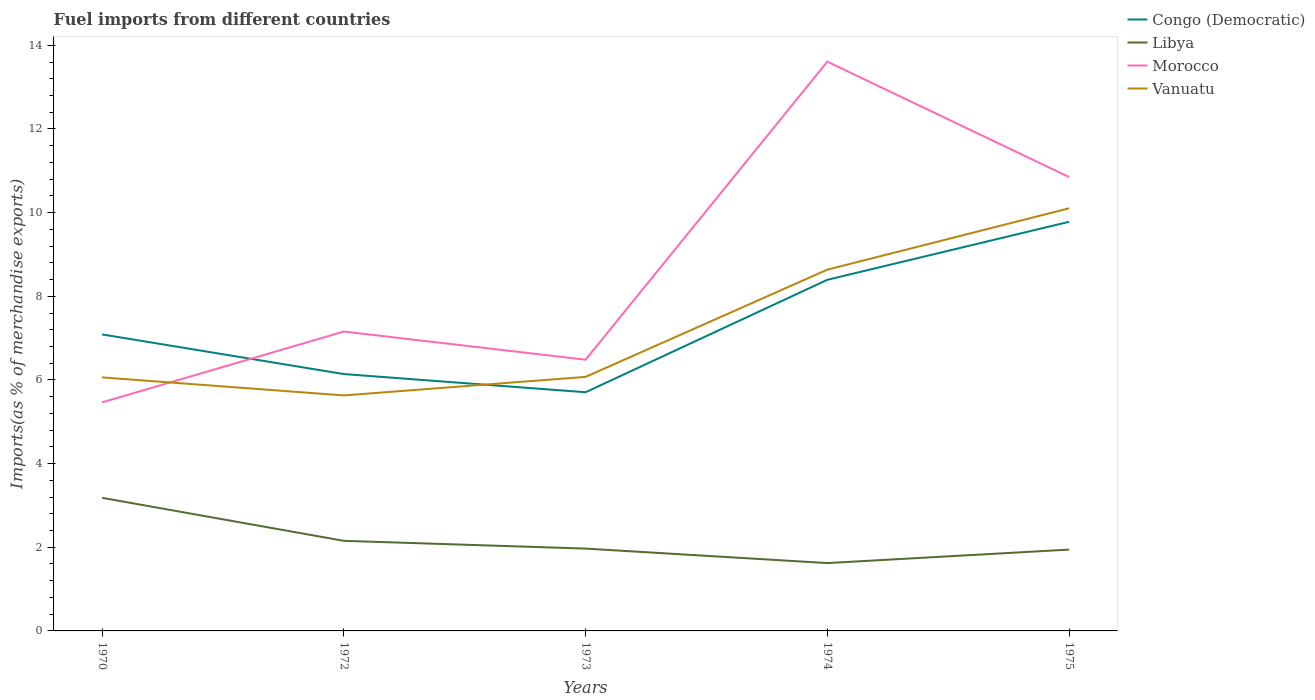How many different coloured lines are there?
Keep it short and to the point. 4. Does the line corresponding to Vanuatu intersect with the line corresponding to Libya?
Provide a succinct answer. No. Is the number of lines equal to the number of legend labels?
Provide a short and direct response. Yes. Across all years, what is the maximum percentage of imports to different countries in Congo (Democratic)?
Your answer should be compact. 5.71. What is the total percentage of imports to different countries in Congo (Democratic) in the graph?
Offer a terse response. 0.95. What is the difference between the highest and the second highest percentage of imports to different countries in Vanuatu?
Keep it short and to the point. 4.47. How many lines are there?
Give a very brief answer. 4. How many years are there in the graph?
Offer a very short reply. 5. Are the values on the major ticks of Y-axis written in scientific E-notation?
Give a very brief answer. No. Does the graph contain any zero values?
Keep it short and to the point. No. Where does the legend appear in the graph?
Ensure brevity in your answer.  Top right. How many legend labels are there?
Give a very brief answer. 4. What is the title of the graph?
Offer a very short reply. Fuel imports from different countries. Does "Finland" appear as one of the legend labels in the graph?
Make the answer very short. No. What is the label or title of the X-axis?
Offer a terse response. Years. What is the label or title of the Y-axis?
Your answer should be compact. Imports(as % of merchandise exports). What is the Imports(as % of merchandise exports) in Congo (Democratic) in 1970?
Ensure brevity in your answer.  7.09. What is the Imports(as % of merchandise exports) in Libya in 1970?
Your answer should be compact. 3.18. What is the Imports(as % of merchandise exports) of Morocco in 1970?
Provide a short and direct response. 5.46. What is the Imports(as % of merchandise exports) in Vanuatu in 1970?
Your response must be concise. 6.06. What is the Imports(as % of merchandise exports) in Congo (Democratic) in 1972?
Provide a succinct answer. 6.14. What is the Imports(as % of merchandise exports) of Libya in 1972?
Your answer should be very brief. 2.15. What is the Imports(as % of merchandise exports) of Morocco in 1972?
Ensure brevity in your answer.  7.16. What is the Imports(as % of merchandise exports) in Vanuatu in 1972?
Your response must be concise. 5.63. What is the Imports(as % of merchandise exports) in Congo (Democratic) in 1973?
Your response must be concise. 5.71. What is the Imports(as % of merchandise exports) in Libya in 1973?
Offer a very short reply. 1.97. What is the Imports(as % of merchandise exports) of Morocco in 1973?
Provide a short and direct response. 6.48. What is the Imports(as % of merchandise exports) in Vanuatu in 1973?
Make the answer very short. 6.07. What is the Imports(as % of merchandise exports) of Congo (Democratic) in 1974?
Offer a terse response. 8.39. What is the Imports(as % of merchandise exports) in Libya in 1974?
Keep it short and to the point. 1.62. What is the Imports(as % of merchandise exports) of Morocco in 1974?
Your answer should be very brief. 13.61. What is the Imports(as % of merchandise exports) of Vanuatu in 1974?
Offer a terse response. 8.64. What is the Imports(as % of merchandise exports) of Congo (Democratic) in 1975?
Your answer should be compact. 9.78. What is the Imports(as % of merchandise exports) in Libya in 1975?
Your response must be concise. 1.94. What is the Imports(as % of merchandise exports) in Morocco in 1975?
Your answer should be compact. 10.85. What is the Imports(as % of merchandise exports) in Vanuatu in 1975?
Your response must be concise. 10.1. Across all years, what is the maximum Imports(as % of merchandise exports) in Congo (Democratic)?
Keep it short and to the point. 9.78. Across all years, what is the maximum Imports(as % of merchandise exports) in Libya?
Offer a terse response. 3.18. Across all years, what is the maximum Imports(as % of merchandise exports) in Morocco?
Ensure brevity in your answer.  13.61. Across all years, what is the maximum Imports(as % of merchandise exports) of Vanuatu?
Ensure brevity in your answer.  10.1. Across all years, what is the minimum Imports(as % of merchandise exports) of Congo (Democratic)?
Offer a terse response. 5.71. Across all years, what is the minimum Imports(as % of merchandise exports) of Libya?
Your answer should be very brief. 1.62. Across all years, what is the minimum Imports(as % of merchandise exports) in Morocco?
Offer a terse response. 5.46. Across all years, what is the minimum Imports(as % of merchandise exports) in Vanuatu?
Make the answer very short. 5.63. What is the total Imports(as % of merchandise exports) of Congo (Democratic) in the graph?
Ensure brevity in your answer.  37.11. What is the total Imports(as % of merchandise exports) of Libya in the graph?
Provide a succinct answer. 10.87. What is the total Imports(as % of merchandise exports) of Morocco in the graph?
Offer a very short reply. 43.57. What is the total Imports(as % of merchandise exports) in Vanuatu in the graph?
Your response must be concise. 36.51. What is the difference between the Imports(as % of merchandise exports) in Congo (Democratic) in 1970 and that in 1972?
Provide a short and direct response. 0.95. What is the difference between the Imports(as % of merchandise exports) in Libya in 1970 and that in 1972?
Make the answer very short. 1.03. What is the difference between the Imports(as % of merchandise exports) of Morocco in 1970 and that in 1972?
Make the answer very short. -1.69. What is the difference between the Imports(as % of merchandise exports) of Vanuatu in 1970 and that in 1972?
Provide a short and direct response. 0.43. What is the difference between the Imports(as % of merchandise exports) in Congo (Democratic) in 1970 and that in 1973?
Offer a very short reply. 1.38. What is the difference between the Imports(as % of merchandise exports) of Libya in 1970 and that in 1973?
Ensure brevity in your answer.  1.21. What is the difference between the Imports(as % of merchandise exports) of Morocco in 1970 and that in 1973?
Your answer should be very brief. -1.02. What is the difference between the Imports(as % of merchandise exports) of Vanuatu in 1970 and that in 1973?
Provide a short and direct response. -0.01. What is the difference between the Imports(as % of merchandise exports) of Congo (Democratic) in 1970 and that in 1974?
Your response must be concise. -1.31. What is the difference between the Imports(as % of merchandise exports) of Libya in 1970 and that in 1974?
Provide a succinct answer. 1.56. What is the difference between the Imports(as % of merchandise exports) of Morocco in 1970 and that in 1974?
Your answer should be compact. -8.15. What is the difference between the Imports(as % of merchandise exports) of Vanuatu in 1970 and that in 1974?
Your response must be concise. -2.58. What is the difference between the Imports(as % of merchandise exports) of Congo (Democratic) in 1970 and that in 1975?
Offer a very short reply. -2.69. What is the difference between the Imports(as % of merchandise exports) of Libya in 1970 and that in 1975?
Offer a very short reply. 1.24. What is the difference between the Imports(as % of merchandise exports) of Morocco in 1970 and that in 1975?
Keep it short and to the point. -5.39. What is the difference between the Imports(as % of merchandise exports) in Vanuatu in 1970 and that in 1975?
Provide a short and direct response. -4.04. What is the difference between the Imports(as % of merchandise exports) of Congo (Democratic) in 1972 and that in 1973?
Offer a very short reply. 0.43. What is the difference between the Imports(as % of merchandise exports) in Libya in 1972 and that in 1973?
Provide a succinct answer. 0.19. What is the difference between the Imports(as % of merchandise exports) in Morocco in 1972 and that in 1973?
Offer a very short reply. 0.67. What is the difference between the Imports(as % of merchandise exports) of Vanuatu in 1972 and that in 1973?
Offer a very short reply. -0.44. What is the difference between the Imports(as % of merchandise exports) of Congo (Democratic) in 1972 and that in 1974?
Ensure brevity in your answer.  -2.25. What is the difference between the Imports(as % of merchandise exports) in Libya in 1972 and that in 1974?
Ensure brevity in your answer.  0.53. What is the difference between the Imports(as % of merchandise exports) of Morocco in 1972 and that in 1974?
Your answer should be compact. -6.45. What is the difference between the Imports(as % of merchandise exports) in Vanuatu in 1972 and that in 1974?
Your answer should be compact. -3.01. What is the difference between the Imports(as % of merchandise exports) in Congo (Democratic) in 1972 and that in 1975?
Keep it short and to the point. -3.64. What is the difference between the Imports(as % of merchandise exports) in Libya in 1972 and that in 1975?
Offer a very short reply. 0.21. What is the difference between the Imports(as % of merchandise exports) of Morocco in 1972 and that in 1975?
Your response must be concise. -3.69. What is the difference between the Imports(as % of merchandise exports) in Vanuatu in 1972 and that in 1975?
Make the answer very short. -4.47. What is the difference between the Imports(as % of merchandise exports) in Congo (Democratic) in 1973 and that in 1974?
Provide a short and direct response. -2.69. What is the difference between the Imports(as % of merchandise exports) of Libya in 1973 and that in 1974?
Your answer should be very brief. 0.35. What is the difference between the Imports(as % of merchandise exports) of Morocco in 1973 and that in 1974?
Provide a succinct answer. -7.13. What is the difference between the Imports(as % of merchandise exports) in Vanuatu in 1973 and that in 1974?
Your answer should be compact. -2.56. What is the difference between the Imports(as % of merchandise exports) of Congo (Democratic) in 1973 and that in 1975?
Your answer should be compact. -4.08. What is the difference between the Imports(as % of merchandise exports) in Libya in 1973 and that in 1975?
Give a very brief answer. 0.02. What is the difference between the Imports(as % of merchandise exports) in Morocco in 1973 and that in 1975?
Provide a succinct answer. -4.37. What is the difference between the Imports(as % of merchandise exports) in Vanuatu in 1973 and that in 1975?
Your answer should be very brief. -4.03. What is the difference between the Imports(as % of merchandise exports) of Congo (Democratic) in 1974 and that in 1975?
Your response must be concise. -1.39. What is the difference between the Imports(as % of merchandise exports) of Libya in 1974 and that in 1975?
Make the answer very short. -0.32. What is the difference between the Imports(as % of merchandise exports) in Morocco in 1974 and that in 1975?
Your answer should be very brief. 2.76. What is the difference between the Imports(as % of merchandise exports) of Vanuatu in 1974 and that in 1975?
Offer a terse response. -1.47. What is the difference between the Imports(as % of merchandise exports) of Congo (Democratic) in 1970 and the Imports(as % of merchandise exports) of Libya in 1972?
Your answer should be very brief. 4.93. What is the difference between the Imports(as % of merchandise exports) in Congo (Democratic) in 1970 and the Imports(as % of merchandise exports) in Morocco in 1972?
Make the answer very short. -0.07. What is the difference between the Imports(as % of merchandise exports) in Congo (Democratic) in 1970 and the Imports(as % of merchandise exports) in Vanuatu in 1972?
Keep it short and to the point. 1.46. What is the difference between the Imports(as % of merchandise exports) in Libya in 1970 and the Imports(as % of merchandise exports) in Morocco in 1972?
Give a very brief answer. -3.98. What is the difference between the Imports(as % of merchandise exports) of Libya in 1970 and the Imports(as % of merchandise exports) of Vanuatu in 1972?
Your answer should be very brief. -2.45. What is the difference between the Imports(as % of merchandise exports) of Morocco in 1970 and the Imports(as % of merchandise exports) of Vanuatu in 1972?
Provide a short and direct response. -0.17. What is the difference between the Imports(as % of merchandise exports) in Congo (Democratic) in 1970 and the Imports(as % of merchandise exports) in Libya in 1973?
Provide a short and direct response. 5.12. What is the difference between the Imports(as % of merchandise exports) of Congo (Democratic) in 1970 and the Imports(as % of merchandise exports) of Morocco in 1973?
Your answer should be very brief. 0.6. What is the difference between the Imports(as % of merchandise exports) in Congo (Democratic) in 1970 and the Imports(as % of merchandise exports) in Vanuatu in 1973?
Your answer should be very brief. 1.02. What is the difference between the Imports(as % of merchandise exports) of Libya in 1970 and the Imports(as % of merchandise exports) of Morocco in 1973?
Your answer should be very brief. -3.3. What is the difference between the Imports(as % of merchandise exports) of Libya in 1970 and the Imports(as % of merchandise exports) of Vanuatu in 1973?
Provide a short and direct response. -2.89. What is the difference between the Imports(as % of merchandise exports) of Morocco in 1970 and the Imports(as % of merchandise exports) of Vanuatu in 1973?
Give a very brief answer. -0.61. What is the difference between the Imports(as % of merchandise exports) of Congo (Democratic) in 1970 and the Imports(as % of merchandise exports) of Libya in 1974?
Give a very brief answer. 5.47. What is the difference between the Imports(as % of merchandise exports) in Congo (Democratic) in 1970 and the Imports(as % of merchandise exports) in Morocco in 1974?
Your answer should be compact. -6.52. What is the difference between the Imports(as % of merchandise exports) of Congo (Democratic) in 1970 and the Imports(as % of merchandise exports) of Vanuatu in 1974?
Provide a succinct answer. -1.55. What is the difference between the Imports(as % of merchandise exports) of Libya in 1970 and the Imports(as % of merchandise exports) of Morocco in 1974?
Offer a very short reply. -10.43. What is the difference between the Imports(as % of merchandise exports) in Libya in 1970 and the Imports(as % of merchandise exports) in Vanuatu in 1974?
Your answer should be very brief. -5.46. What is the difference between the Imports(as % of merchandise exports) in Morocco in 1970 and the Imports(as % of merchandise exports) in Vanuatu in 1974?
Offer a terse response. -3.17. What is the difference between the Imports(as % of merchandise exports) in Congo (Democratic) in 1970 and the Imports(as % of merchandise exports) in Libya in 1975?
Give a very brief answer. 5.14. What is the difference between the Imports(as % of merchandise exports) in Congo (Democratic) in 1970 and the Imports(as % of merchandise exports) in Morocco in 1975?
Offer a very short reply. -3.76. What is the difference between the Imports(as % of merchandise exports) of Congo (Democratic) in 1970 and the Imports(as % of merchandise exports) of Vanuatu in 1975?
Ensure brevity in your answer.  -3.02. What is the difference between the Imports(as % of merchandise exports) in Libya in 1970 and the Imports(as % of merchandise exports) in Morocco in 1975?
Keep it short and to the point. -7.67. What is the difference between the Imports(as % of merchandise exports) of Libya in 1970 and the Imports(as % of merchandise exports) of Vanuatu in 1975?
Offer a terse response. -6.92. What is the difference between the Imports(as % of merchandise exports) in Morocco in 1970 and the Imports(as % of merchandise exports) in Vanuatu in 1975?
Give a very brief answer. -4.64. What is the difference between the Imports(as % of merchandise exports) of Congo (Democratic) in 1972 and the Imports(as % of merchandise exports) of Libya in 1973?
Your answer should be compact. 4.17. What is the difference between the Imports(as % of merchandise exports) in Congo (Democratic) in 1972 and the Imports(as % of merchandise exports) in Morocco in 1973?
Your answer should be very brief. -0.34. What is the difference between the Imports(as % of merchandise exports) in Congo (Democratic) in 1972 and the Imports(as % of merchandise exports) in Vanuatu in 1973?
Your answer should be very brief. 0.07. What is the difference between the Imports(as % of merchandise exports) in Libya in 1972 and the Imports(as % of merchandise exports) in Morocco in 1973?
Your answer should be very brief. -4.33. What is the difference between the Imports(as % of merchandise exports) of Libya in 1972 and the Imports(as % of merchandise exports) of Vanuatu in 1973?
Provide a succinct answer. -3.92. What is the difference between the Imports(as % of merchandise exports) in Morocco in 1972 and the Imports(as % of merchandise exports) in Vanuatu in 1973?
Your response must be concise. 1.08. What is the difference between the Imports(as % of merchandise exports) in Congo (Democratic) in 1972 and the Imports(as % of merchandise exports) in Libya in 1974?
Your response must be concise. 4.52. What is the difference between the Imports(as % of merchandise exports) of Congo (Democratic) in 1972 and the Imports(as % of merchandise exports) of Morocco in 1974?
Your response must be concise. -7.47. What is the difference between the Imports(as % of merchandise exports) of Congo (Democratic) in 1972 and the Imports(as % of merchandise exports) of Vanuatu in 1974?
Keep it short and to the point. -2.5. What is the difference between the Imports(as % of merchandise exports) in Libya in 1972 and the Imports(as % of merchandise exports) in Morocco in 1974?
Your response must be concise. -11.46. What is the difference between the Imports(as % of merchandise exports) of Libya in 1972 and the Imports(as % of merchandise exports) of Vanuatu in 1974?
Your answer should be very brief. -6.48. What is the difference between the Imports(as % of merchandise exports) in Morocco in 1972 and the Imports(as % of merchandise exports) in Vanuatu in 1974?
Ensure brevity in your answer.  -1.48. What is the difference between the Imports(as % of merchandise exports) in Congo (Democratic) in 1972 and the Imports(as % of merchandise exports) in Libya in 1975?
Your answer should be compact. 4.2. What is the difference between the Imports(as % of merchandise exports) of Congo (Democratic) in 1972 and the Imports(as % of merchandise exports) of Morocco in 1975?
Provide a succinct answer. -4.71. What is the difference between the Imports(as % of merchandise exports) of Congo (Democratic) in 1972 and the Imports(as % of merchandise exports) of Vanuatu in 1975?
Keep it short and to the point. -3.96. What is the difference between the Imports(as % of merchandise exports) in Libya in 1972 and the Imports(as % of merchandise exports) in Morocco in 1975?
Provide a short and direct response. -8.7. What is the difference between the Imports(as % of merchandise exports) in Libya in 1972 and the Imports(as % of merchandise exports) in Vanuatu in 1975?
Keep it short and to the point. -7.95. What is the difference between the Imports(as % of merchandise exports) in Morocco in 1972 and the Imports(as % of merchandise exports) in Vanuatu in 1975?
Make the answer very short. -2.95. What is the difference between the Imports(as % of merchandise exports) in Congo (Democratic) in 1973 and the Imports(as % of merchandise exports) in Libya in 1974?
Give a very brief answer. 4.08. What is the difference between the Imports(as % of merchandise exports) of Congo (Democratic) in 1973 and the Imports(as % of merchandise exports) of Morocco in 1974?
Your answer should be very brief. -7.9. What is the difference between the Imports(as % of merchandise exports) in Congo (Democratic) in 1973 and the Imports(as % of merchandise exports) in Vanuatu in 1974?
Provide a succinct answer. -2.93. What is the difference between the Imports(as % of merchandise exports) in Libya in 1973 and the Imports(as % of merchandise exports) in Morocco in 1974?
Your answer should be very brief. -11.64. What is the difference between the Imports(as % of merchandise exports) in Libya in 1973 and the Imports(as % of merchandise exports) in Vanuatu in 1974?
Provide a succinct answer. -6.67. What is the difference between the Imports(as % of merchandise exports) in Morocco in 1973 and the Imports(as % of merchandise exports) in Vanuatu in 1974?
Offer a terse response. -2.15. What is the difference between the Imports(as % of merchandise exports) of Congo (Democratic) in 1973 and the Imports(as % of merchandise exports) of Libya in 1975?
Your response must be concise. 3.76. What is the difference between the Imports(as % of merchandise exports) in Congo (Democratic) in 1973 and the Imports(as % of merchandise exports) in Morocco in 1975?
Make the answer very short. -5.14. What is the difference between the Imports(as % of merchandise exports) in Congo (Democratic) in 1973 and the Imports(as % of merchandise exports) in Vanuatu in 1975?
Keep it short and to the point. -4.4. What is the difference between the Imports(as % of merchandise exports) in Libya in 1973 and the Imports(as % of merchandise exports) in Morocco in 1975?
Provide a succinct answer. -8.88. What is the difference between the Imports(as % of merchandise exports) of Libya in 1973 and the Imports(as % of merchandise exports) of Vanuatu in 1975?
Your answer should be very brief. -8.14. What is the difference between the Imports(as % of merchandise exports) of Morocco in 1973 and the Imports(as % of merchandise exports) of Vanuatu in 1975?
Your answer should be very brief. -3.62. What is the difference between the Imports(as % of merchandise exports) of Congo (Democratic) in 1974 and the Imports(as % of merchandise exports) of Libya in 1975?
Provide a short and direct response. 6.45. What is the difference between the Imports(as % of merchandise exports) in Congo (Democratic) in 1974 and the Imports(as % of merchandise exports) in Morocco in 1975?
Your response must be concise. -2.46. What is the difference between the Imports(as % of merchandise exports) of Congo (Democratic) in 1974 and the Imports(as % of merchandise exports) of Vanuatu in 1975?
Give a very brief answer. -1.71. What is the difference between the Imports(as % of merchandise exports) of Libya in 1974 and the Imports(as % of merchandise exports) of Morocco in 1975?
Your answer should be compact. -9.23. What is the difference between the Imports(as % of merchandise exports) in Libya in 1974 and the Imports(as % of merchandise exports) in Vanuatu in 1975?
Offer a very short reply. -8.48. What is the difference between the Imports(as % of merchandise exports) in Morocco in 1974 and the Imports(as % of merchandise exports) in Vanuatu in 1975?
Offer a very short reply. 3.51. What is the average Imports(as % of merchandise exports) in Congo (Democratic) per year?
Your answer should be very brief. 7.42. What is the average Imports(as % of merchandise exports) in Libya per year?
Keep it short and to the point. 2.17. What is the average Imports(as % of merchandise exports) in Morocco per year?
Offer a very short reply. 8.71. What is the average Imports(as % of merchandise exports) of Vanuatu per year?
Your answer should be very brief. 7.3. In the year 1970, what is the difference between the Imports(as % of merchandise exports) in Congo (Democratic) and Imports(as % of merchandise exports) in Libya?
Your answer should be very brief. 3.91. In the year 1970, what is the difference between the Imports(as % of merchandise exports) of Congo (Democratic) and Imports(as % of merchandise exports) of Morocco?
Offer a terse response. 1.62. In the year 1970, what is the difference between the Imports(as % of merchandise exports) of Congo (Democratic) and Imports(as % of merchandise exports) of Vanuatu?
Make the answer very short. 1.03. In the year 1970, what is the difference between the Imports(as % of merchandise exports) in Libya and Imports(as % of merchandise exports) in Morocco?
Make the answer very short. -2.28. In the year 1970, what is the difference between the Imports(as % of merchandise exports) of Libya and Imports(as % of merchandise exports) of Vanuatu?
Offer a very short reply. -2.88. In the year 1970, what is the difference between the Imports(as % of merchandise exports) of Morocco and Imports(as % of merchandise exports) of Vanuatu?
Provide a short and direct response. -0.6. In the year 1972, what is the difference between the Imports(as % of merchandise exports) of Congo (Democratic) and Imports(as % of merchandise exports) of Libya?
Provide a short and direct response. 3.99. In the year 1972, what is the difference between the Imports(as % of merchandise exports) of Congo (Democratic) and Imports(as % of merchandise exports) of Morocco?
Your answer should be compact. -1.02. In the year 1972, what is the difference between the Imports(as % of merchandise exports) in Congo (Democratic) and Imports(as % of merchandise exports) in Vanuatu?
Provide a succinct answer. 0.51. In the year 1972, what is the difference between the Imports(as % of merchandise exports) of Libya and Imports(as % of merchandise exports) of Morocco?
Your answer should be very brief. -5. In the year 1972, what is the difference between the Imports(as % of merchandise exports) of Libya and Imports(as % of merchandise exports) of Vanuatu?
Make the answer very short. -3.48. In the year 1972, what is the difference between the Imports(as % of merchandise exports) of Morocco and Imports(as % of merchandise exports) of Vanuatu?
Provide a short and direct response. 1.53. In the year 1973, what is the difference between the Imports(as % of merchandise exports) of Congo (Democratic) and Imports(as % of merchandise exports) of Libya?
Offer a terse response. 3.74. In the year 1973, what is the difference between the Imports(as % of merchandise exports) in Congo (Democratic) and Imports(as % of merchandise exports) in Morocco?
Ensure brevity in your answer.  -0.78. In the year 1973, what is the difference between the Imports(as % of merchandise exports) in Congo (Democratic) and Imports(as % of merchandise exports) in Vanuatu?
Ensure brevity in your answer.  -0.37. In the year 1973, what is the difference between the Imports(as % of merchandise exports) in Libya and Imports(as % of merchandise exports) in Morocco?
Provide a succinct answer. -4.52. In the year 1973, what is the difference between the Imports(as % of merchandise exports) of Libya and Imports(as % of merchandise exports) of Vanuatu?
Provide a short and direct response. -4.11. In the year 1973, what is the difference between the Imports(as % of merchandise exports) in Morocco and Imports(as % of merchandise exports) in Vanuatu?
Make the answer very short. 0.41. In the year 1974, what is the difference between the Imports(as % of merchandise exports) of Congo (Democratic) and Imports(as % of merchandise exports) of Libya?
Offer a terse response. 6.77. In the year 1974, what is the difference between the Imports(as % of merchandise exports) of Congo (Democratic) and Imports(as % of merchandise exports) of Morocco?
Your answer should be compact. -5.22. In the year 1974, what is the difference between the Imports(as % of merchandise exports) of Congo (Democratic) and Imports(as % of merchandise exports) of Vanuatu?
Provide a short and direct response. -0.24. In the year 1974, what is the difference between the Imports(as % of merchandise exports) in Libya and Imports(as % of merchandise exports) in Morocco?
Your response must be concise. -11.99. In the year 1974, what is the difference between the Imports(as % of merchandise exports) in Libya and Imports(as % of merchandise exports) in Vanuatu?
Keep it short and to the point. -7.02. In the year 1974, what is the difference between the Imports(as % of merchandise exports) in Morocco and Imports(as % of merchandise exports) in Vanuatu?
Offer a terse response. 4.97. In the year 1975, what is the difference between the Imports(as % of merchandise exports) in Congo (Democratic) and Imports(as % of merchandise exports) in Libya?
Provide a succinct answer. 7.84. In the year 1975, what is the difference between the Imports(as % of merchandise exports) of Congo (Democratic) and Imports(as % of merchandise exports) of Morocco?
Keep it short and to the point. -1.07. In the year 1975, what is the difference between the Imports(as % of merchandise exports) in Congo (Democratic) and Imports(as % of merchandise exports) in Vanuatu?
Make the answer very short. -0.32. In the year 1975, what is the difference between the Imports(as % of merchandise exports) in Libya and Imports(as % of merchandise exports) in Morocco?
Make the answer very short. -8.91. In the year 1975, what is the difference between the Imports(as % of merchandise exports) of Libya and Imports(as % of merchandise exports) of Vanuatu?
Offer a terse response. -8.16. In the year 1975, what is the difference between the Imports(as % of merchandise exports) in Morocco and Imports(as % of merchandise exports) in Vanuatu?
Make the answer very short. 0.75. What is the ratio of the Imports(as % of merchandise exports) in Congo (Democratic) in 1970 to that in 1972?
Provide a short and direct response. 1.15. What is the ratio of the Imports(as % of merchandise exports) of Libya in 1970 to that in 1972?
Provide a short and direct response. 1.48. What is the ratio of the Imports(as % of merchandise exports) in Morocco in 1970 to that in 1972?
Your answer should be compact. 0.76. What is the ratio of the Imports(as % of merchandise exports) in Vanuatu in 1970 to that in 1972?
Provide a succinct answer. 1.08. What is the ratio of the Imports(as % of merchandise exports) of Congo (Democratic) in 1970 to that in 1973?
Provide a short and direct response. 1.24. What is the ratio of the Imports(as % of merchandise exports) in Libya in 1970 to that in 1973?
Your answer should be very brief. 1.62. What is the ratio of the Imports(as % of merchandise exports) in Morocco in 1970 to that in 1973?
Your answer should be compact. 0.84. What is the ratio of the Imports(as % of merchandise exports) of Congo (Democratic) in 1970 to that in 1974?
Provide a short and direct response. 0.84. What is the ratio of the Imports(as % of merchandise exports) in Libya in 1970 to that in 1974?
Your response must be concise. 1.96. What is the ratio of the Imports(as % of merchandise exports) of Morocco in 1970 to that in 1974?
Offer a terse response. 0.4. What is the ratio of the Imports(as % of merchandise exports) in Vanuatu in 1970 to that in 1974?
Make the answer very short. 0.7. What is the ratio of the Imports(as % of merchandise exports) of Congo (Democratic) in 1970 to that in 1975?
Provide a short and direct response. 0.72. What is the ratio of the Imports(as % of merchandise exports) of Libya in 1970 to that in 1975?
Make the answer very short. 1.64. What is the ratio of the Imports(as % of merchandise exports) in Morocco in 1970 to that in 1975?
Offer a very short reply. 0.5. What is the ratio of the Imports(as % of merchandise exports) in Vanuatu in 1970 to that in 1975?
Provide a succinct answer. 0.6. What is the ratio of the Imports(as % of merchandise exports) in Congo (Democratic) in 1972 to that in 1973?
Your response must be concise. 1.08. What is the ratio of the Imports(as % of merchandise exports) of Libya in 1972 to that in 1973?
Your answer should be very brief. 1.09. What is the ratio of the Imports(as % of merchandise exports) of Morocco in 1972 to that in 1973?
Offer a very short reply. 1.1. What is the ratio of the Imports(as % of merchandise exports) of Vanuatu in 1972 to that in 1973?
Give a very brief answer. 0.93. What is the ratio of the Imports(as % of merchandise exports) of Congo (Democratic) in 1972 to that in 1974?
Your answer should be very brief. 0.73. What is the ratio of the Imports(as % of merchandise exports) in Libya in 1972 to that in 1974?
Make the answer very short. 1.33. What is the ratio of the Imports(as % of merchandise exports) of Morocco in 1972 to that in 1974?
Ensure brevity in your answer.  0.53. What is the ratio of the Imports(as % of merchandise exports) in Vanuatu in 1972 to that in 1974?
Offer a very short reply. 0.65. What is the ratio of the Imports(as % of merchandise exports) of Congo (Democratic) in 1972 to that in 1975?
Provide a succinct answer. 0.63. What is the ratio of the Imports(as % of merchandise exports) of Libya in 1972 to that in 1975?
Provide a short and direct response. 1.11. What is the ratio of the Imports(as % of merchandise exports) of Morocco in 1972 to that in 1975?
Offer a very short reply. 0.66. What is the ratio of the Imports(as % of merchandise exports) in Vanuatu in 1972 to that in 1975?
Your answer should be very brief. 0.56. What is the ratio of the Imports(as % of merchandise exports) of Congo (Democratic) in 1973 to that in 1974?
Your answer should be compact. 0.68. What is the ratio of the Imports(as % of merchandise exports) in Libya in 1973 to that in 1974?
Your answer should be compact. 1.21. What is the ratio of the Imports(as % of merchandise exports) of Morocco in 1973 to that in 1974?
Keep it short and to the point. 0.48. What is the ratio of the Imports(as % of merchandise exports) in Vanuatu in 1973 to that in 1974?
Provide a succinct answer. 0.7. What is the ratio of the Imports(as % of merchandise exports) in Congo (Democratic) in 1973 to that in 1975?
Make the answer very short. 0.58. What is the ratio of the Imports(as % of merchandise exports) of Libya in 1973 to that in 1975?
Provide a short and direct response. 1.01. What is the ratio of the Imports(as % of merchandise exports) in Morocco in 1973 to that in 1975?
Offer a terse response. 0.6. What is the ratio of the Imports(as % of merchandise exports) in Vanuatu in 1973 to that in 1975?
Offer a very short reply. 0.6. What is the ratio of the Imports(as % of merchandise exports) of Congo (Democratic) in 1974 to that in 1975?
Keep it short and to the point. 0.86. What is the ratio of the Imports(as % of merchandise exports) of Libya in 1974 to that in 1975?
Offer a very short reply. 0.83. What is the ratio of the Imports(as % of merchandise exports) of Morocco in 1974 to that in 1975?
Give a very brief answer. 1.25. What is the ratio of the Imports(as % of merchandise exports) of Vanuatu in 1974 to that in 1975?
Provide a succinct answer. 0.85. What is the difference between the highest and the second highest Imports(as % of merchandise exports) in Congo (Democratic)?
Offer a very short reply. 1.39. What is the difference between the highest and the second highest Imports(as % of merchandise exports) in Libya?
Provide a short and direct response. 1.03. What is the difference between the highest and the second highest Imports(as % of merchandise exports) in Morocco?
Your answer should be very brief. 2.76. What is the difference between the highest and the second highest Imports(as % of merchandise exports) of Vanuatu?
Offer a very short reply. 1.47. What is the difference between the highest and the lowest Imports(as % of merchandise exports) in Congo (Democratic)?
Ensure brevity in your answer.  4.08. What is the difference between the highest and the lowest Imports(as % of merchandise exports) in Libya?
Offer a terse response. 1.56. What is the difference between the highest and the lowest Imports(as % of merchandise exports) of Morocco?
Provide a succinct answer. 8.15. What is the difference between the highest and the lowest Imports(as % of merchandise exports) in Vanuatu?
Give a very brief answer. 4.47. 